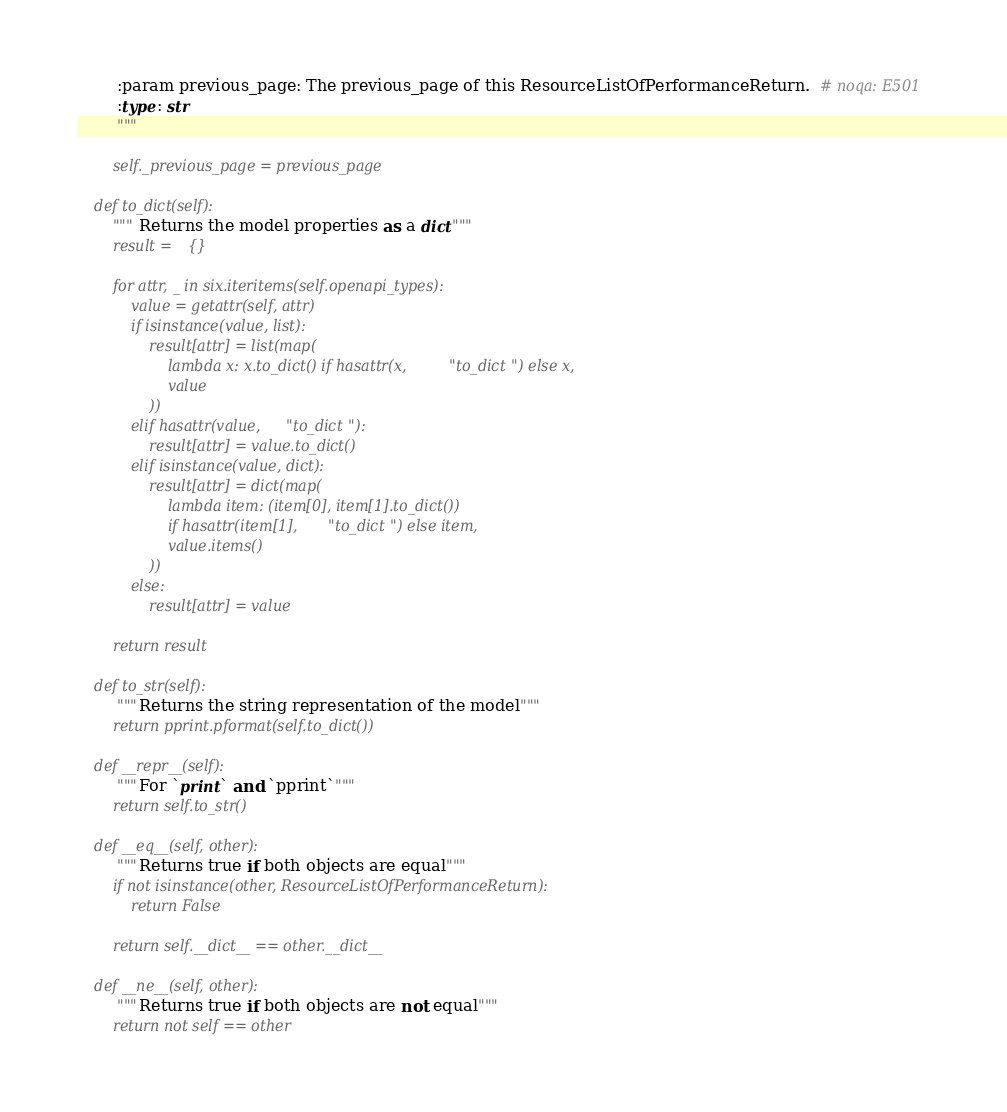Convert code to text. <code><loc_0><loc_0><loc_500><loc_500><_Python_>        :param previous_page: The previous_page of this ResourceListOfPerformanceReturn.  # noqa: E501
        :type: str
        """

        self._previous_page = previous_page

    def to_dict(self):
        """Returns the model properties as a dict"""
        result = {}

        for attr, _ in six.iteritems(self.openapi_types):
            value = getattr(self, attr)
            if isinstance(value, list):
                result[attr] = list(map(
                    lambda x: x.to_dict() if hasattr(x, "to_dict") else x,
                    value
                ))
            elif hasattr(value, "to_dict"):
                result[attr] = value.to_dict()
            elif isinstance(value, dict):
                result[attr] = dict(map(
                    lambda item: (item[0], item[1].to_dict())
                    if hasattr(item[1], "to_dict") else item,
                    value.items()
                ))
            else:
                result[attr] = value

        return result

    def to_str(self):
        """Returns the string representation of the model"""
        return pprint.pformat(self.to_dict())

    def __repr__(self):
        """For `print` and `pprint`"""
        return self.to_str()

    def __eq__(self, other):
        """Returns true if both objects are equal"""
        if not isinstance(other, ResourceListOfPerformanceReturn):
            return False

        return self.__dict__ == other.__dict__

    def __ne__(self, other):
        """Returns true if both objects are not equal"""
        return not self == other
</code> 